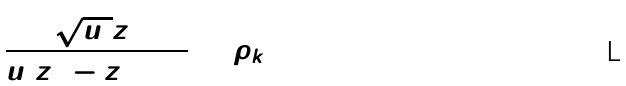<formula> <loc_0><loc_0><loc_500><loc_500>\frac { \sqrt { u _ { 0 } } z _ { 0 } } { u _ { 0 } z _ { 0 } ^ { 2 } - z _ { 0 } + 1 } = \rho _ { k }</formula> 